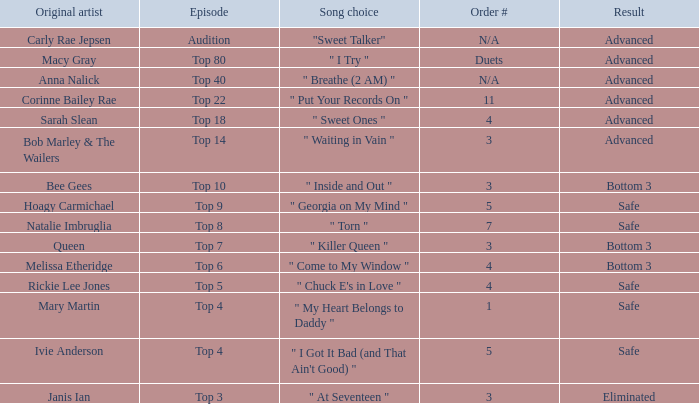What's the total number of songs originally performed by Anna Nalick? 1.0. Can you give me this table as a dict? {'header': ['Original artist', 'Episode', 'Song choice', 'Order #', 'Result'], 'rows': [['Carly Rae Jepsen', 'Audition', '"Sweet Talker"', 'N/A', 'Advanced'], ['Macy Gray', 'Top 80', '" I Try "', 'Duets', 'Advanced'], ['Anna Nalick', 'Top 40', '" Breathe (2 AM) "', 'N/A', 'Advanced'], ['Corinne Bailey Rae', 'Top 22', '" Put Your Records On "', '11', 'Advanced'], ['Sarah Slean', 'Top 18', '" Sweet Ones "', '4', 'Advanced'], ['Bob Marley & The Wailers', 'Top 14', '" Waiting in Vain "', '3', 'Advanced'], ['Bee Gees', 'Top 10', '" Inside and Out "', '3', 'Bottom 3'], ['Hoagy Carmichael', 'Top 9', '" Georgia on My Mind "', '5', 'Safe'], ['Natalie Imbruglia', 'Top 8', '" Torn "', '7', 'Safe'], ['Queen', 'Top 7', '" Killer Queen "', '3', 'Bottom 3'], ['Melissa Etheridge', 'Top 6', '" Come to My Window "', '4', 'Bottom 3'], ['Rickie Lee Jones', 'Top 5', '" Chuck E\'s in Love "', '4', 'Safe'], ['Mary Martin', 'Top 4', '" My Heart Belongs to Daddy "', '1', 'Safe'], ['Ivie Anderson', 'Top 4', '" I Got It Bad (and That Ain\'t Good) "', '5', 'Safe'], ['Janis Ian', 'Top 3', '" At Seventeen "', '3', 'Eliminated']]} 